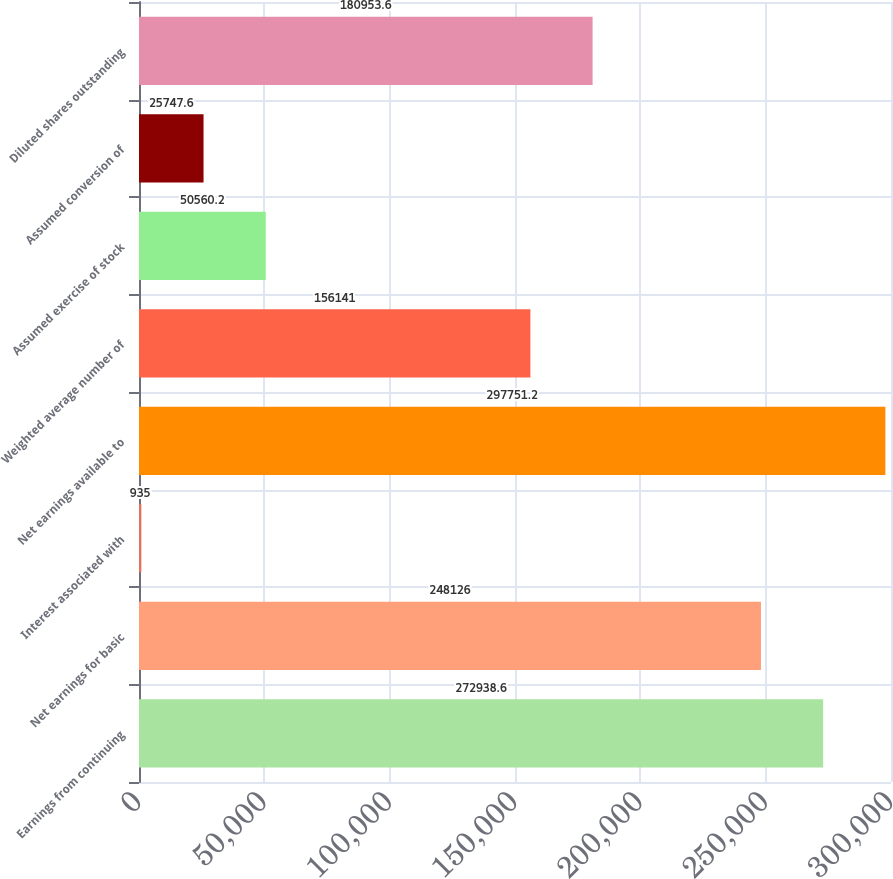Convert chart to OTSL. <chart><loc_0><loc_0><loc_500><loc_500><bar_chart><fcel>Earnings from continuing<fcel>Net earnings for basic<fcel>Interest associated with<fcel>Net earnings available to<fcel>Weighted average number of<fcel>Assumed exercise of stock<fcel>Assumed conversion of<fcel>Diluted shares outstanding<nl><fcel>272939<fcel>248126<fcel>935<fcel>297751<fcel>156141<fcel>50560.2<fcel>25747.6<fcel>180954<nl></chart> 